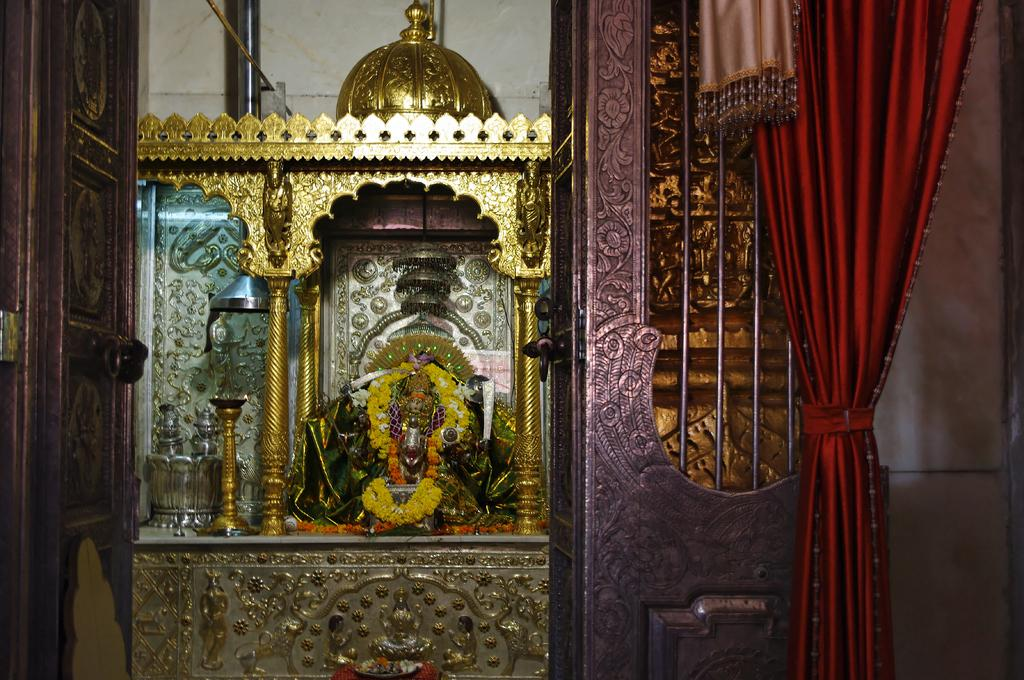What type of building is shown in the image? The image shows the inner view of a temple. What can be seen inside the temple? There is an idol of a god with a garland in the temple. What is the source of light visible in the image? A diya is visible to the left in the image. How can one enter or exit the temple? There is a door in the temple. What type of window treatment is present in the temple? Curtains are present in the temple. What page of the book is the god holding in the image? There is no book or page present in the image; it shows an idol of a god with a garland. 